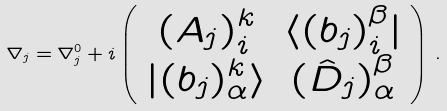Convert formula to latex. <formula><loc_0><loc_0><loc_500><loc_500>\nabla _ { j } = \nabla ^ { 0 } _ { j } + i \left ( \begin{array} { c c } ( A _ { j } ) ^ { k } _ { i } & \langle ( b _ { j } ) _ { i } ^ { \beta } | \\ | ( b _ { j } ) ^ { k } _ { \alpha } \rangle & ( \hat { D } _ { j } ) _ { \alpha } ^ { \beta } \end{array} \right ) \, .</formula> 